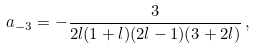<formula> <loc_0><loc_0><loc_500><loc_500>a _ { - 3 } = - \frac { 3 } { 2 l ( 1 + l ) ( 2 l - 1 ) ( 3 + 2 l ) } \, ,</formula> 